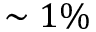Convert formula to latex. <formula><loc_0><loc_0><loc_500><loc_500>\sim 1 \%</formula> 